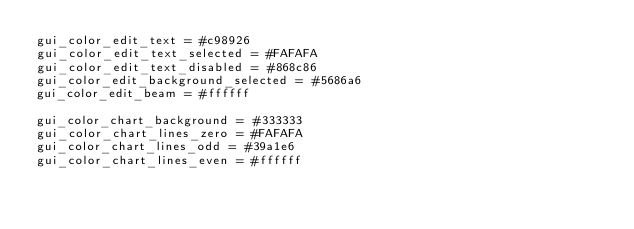<code> <loc_0><loc_0><loc_500><loc_500><_SQL_>gui_color_edit_text = #c98926
gui_color_edit_text_selected = #FAFAFA
gui_color_edit_text_disabled = #868c86
gui_color_edit_background_selected = #5686a6
gui_color_edit_beam = #ffffff

gui_color_chart_background = #333333
gui_color_chart_lines_zero = #FAFAFA
gui_color_chart_lines_odd = #39a1e6
gui_color_chart_lines_even = #ffffff
</code> 